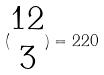<formula> <loc_0><loc_0><loc_500><loc_500>( \begin{matrix} 1 2 \\ 3 \end{matrix} ) = 2 2 0</formula> 